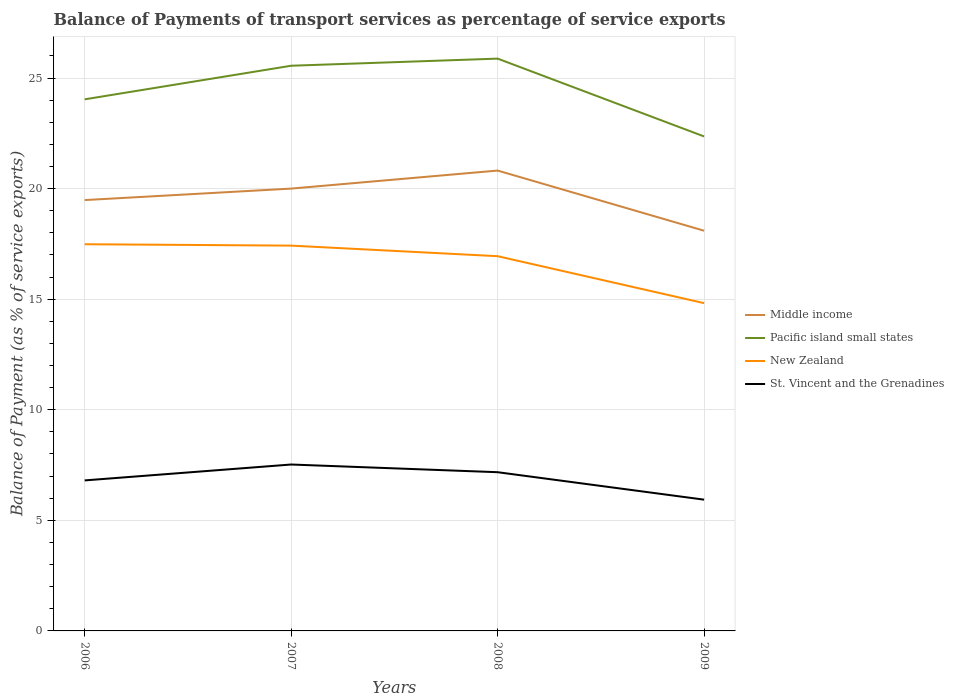Is the number of lines equal to the number of legend labels?
Make the answer very short. Yes. Across all years, what is the maximum balance of payments of transport services in St. Vincent and the Grenadines?
Ensure brevity in your answer.  5.94. In which year was the balance of payments of transport services in Pacific island small states maximum?
Provide a short and direct response. 2009. What is the total balance of payments of transport services in Pacific island small states in the graph?
Give a very brief answer. -0.32. What is the difference between the highest and the second highest balance of payments of transport services in Middle income?
Your answer should be compact. 2.72. What is the difference between the highest and the lowest balance of payments of transport services in St. Vincent and the Grenadines?
Ensure brevity in your answer.  2. How many lines are there?
Give a very brief answer. 4. What is the difference between two consecutive major ticks on the Y-axis?
Your answer should be compact. 5. Are the values on the major ticks of Y-axis written in scientific E-notation?
Provide a succinct answer. No. Does the graph contain any zero values?
Your answer should be very brief. No. How are the legend labels stacked?
Make the answer very short. Vertical. What is the title of the graph?
Your answer should be compact. Balance of Payments of transport services as percentage of service exports. Does "Libya" appear as one of the legend labels in the graph?
Your response must be concise. No. What is the label or title of the Y-axis?
Keep it short and to the point. Balance of Payment (as % of service exports). What is the Balance of Payment (as % of service exports) of Middle income in 2006?
Keep it short and to the point. 19.48. What is the Balance of Payment (as % of service exports) in Pacific island small states in 2006?
Make the answer very short. 24.04. What is the Balance of Payment (as % of service exports) of New Zealand in 2006?
Ensure brevity in your answer.  17.48. What is the Balance of Payment (as % of service exports) of St. Vincent and the Grenadines in 2006?
Offer a very short reply. 6.81. What is the Balance of Payment (as % of service exports) in Middle income in 2007?
Your response must be concise. 20. What is the Balance of Payment (as % of service exports) in Pacific island small states in 2007?
Offer a very short reply. 25.56. What is the Balance of Payment (as % of service exports) in New Zealand in 2007?
Your response must be concise. 17.42. What is the Balance of Payment (as % of service exports) of St. Vincent and the Grenadines in 2007?
Provide a short and direct response. 7.52. What is the Balance of Payment (as % of service exports) in Middle income in 2008?
Give a very brief answer. 20.82. What is the Balance of Payment (as % of service exports) of Pacific island small states in 2008?
Keep it short and to the point. 25.88. What is the Balance of Payment (as % of service exports) of New Zealand in 2008?
Give a very brief answer. 16.94. What is the Balance of Payment (as % of service exports) of St. Vincent and the Grenadines in 2008?
Give a very brief answer. 7.18. What is the Balance of Payment (as % of service exports) of Middle income in 2009?
Your response must be concise. 18.1. What is the Balance of Payment (as % of service exports) of Pacific island small states in 2009?
Give a very brief answer. 22.36. What is the Balance of Payment (as % of service exports) in New Zealand in 2009?
Make the answer very short. 14.82. What is the Balance of Payment (as % of service exports) of St. Vincent and the Grenadines in 2009?
Provide a short and direct response. 5.94. Across all years, what is the maximum Balance of Payment (as % of service exports) in Middle income?
Provide a short and direct response. 20.82. Across all years, what is the maximum Balance of Payment (as % of service exports) in Pacific island small states?
Your response must be concise. 25.88. Across all years, what is the maximum Balance of Payment (as % of service exports) in New Zealand?
Your answer should be compact. 17.48. Across all years, what is the maximum Balance of Payment (as % of service exports) in St. Vincent and the Grenadines?
Make the answer very short. 7.52. Across all years, what is the minimum Balance of Payment (as % of service exports) of Middle income?
Give a very brief answer. 18.1. Across all years, what is the minimum Balance of Payment (as % of service exports) of Pacific island small states?
Offer a very short reply. 22.36. Across all years, what is the minimum Balance of Payment (as % of service exports) in New Zealand?
Provide a succinct answer. 14.82. Across all years, what is the minimum Balance of Payment (as % of service exports) of St. Vincent and the Grenadines?
Your response must be concise. 5.94. What is the total Balance of Payment (as % of service exports) in Middle income in the graph?
Give a very brief answer. 78.39. What is the total Balance of Payment (as % of service exports) in Pacific island small states in the graph?
Your response must be concise. 97.83. What is the total Balance of Payment (as % of service exports) of New Zealand in the graph?
Give a very brief answer. 66.67. What is the total Balance of Payment (as % of service exports) of St. Vincent and the Grenadines in the graph?
Offer a very short reply. 27.44. What is the difference between the Balance of Payment (as % of service exports) in Middle income in 2006 and that in 2007?
Provide a short and direct response. -0.52. What is the difference between the Balance of Payment (as % of service exports) of Pacific island small states in 2006 and that in 2007?
Give a very brief answer. -1.52. What is the difference between the Balance of Payment (as % of service exports) of New Zealand in 2006 and that in 2007?
Keep it short and to the point. 0.06. What is the difference between the Balance of Payment (as % of service exports) in St. Vincent and the Grenadines in 2006 and that in 2007?
Offer a terse response. -0.72. What is the difference between the Balance of Payment (as % of service exports) in Middle income in 2006 and that in 2008?
Your answer should be compact. -1.33. What is the difference between the Balance of Payment (as % of service exports) of Pacific island small states in 2006 and that in 2008?
Your response must be concise. -1.84. What is the difference between the Balance of Payment (as % of service exports) of New Zealand in 2006 and that in 2008?
Ensure brevity in your answer.  0.54. What is the difference between the Balance of Payment (as % of service exports) in St. Vincent and the Grenadines in 2006 and that in 2008?
Your response must be concise. -0.37. What is the difference between the Balance of Payment (as % of service exports) in Middle income in 2006 and that in 2009?
Ensure brevity in your answer.  1.39. What is the difference between the Balance of Payment (as % of service exports) in Pacific island small states in 2006 and that in 2009?
Make the answer very short. 1.68. What is the difference between the Balance of Payment (as % of service exports) in New Zealand in 2006 and that in 2009?
Provide a succinct answer. 2.66. What is the difference between the Balance of Payment (as % of service exports) of St. Vincent and the Grenadines in 2006 and that in 2009?
Provide a short and direct response. 0.87. What is the difference between the Balance of Payment (as % of service exports) in Middle income in 2007 and that in 2008?
Provide a succinct answer. -0.82. What is the difference between the Balance of Payment (as % of service exports) of Pacific island small states in 2007 and that in 2008?
Make the answer very short. -0.32. What is the difference between the Balance of Payment (as % of service exports) of New Zealand in 2007 and that in 2008?
Provide a succinct answer. 0.48. What is the difference between the Balance of Payment (as % of service exports) in St. Vincent and the Grenadines in 2007 and that in 2008?
Make the answer very short. 0.35. What is the difference between the Balance of Payment (as % of service exports) of Middle income in 2007 and that in 2009?
Make the answer very short. 1.91. What is the difference between the Balance of Payment (as % of service exports) in Pacific island small states in 2007 and that in 2009?
Offer a very short reply. 3.2. What is the difference between the Balance of Payment (as % of service exports) in New Zealand in 2007 and that in 2009?
Offer a terse response. 2.6. What is the difference between the Balance of Payment (as % of service exports) in St. Vincent and the Grenadines in 2007 and that in 2009?
Offer a very short reply. 1.59. What is the difference between the Balance of Payment (as % of service exports) in Middle income in 2008 and that in 2009?
Keep it short and to the point. 2.72. What is the difference between the Balance of Payment (as % of service exports) of Pacific island small states in 2008 and that in 2009?
Your answer should be very brief. 3.52. What is the difference between the Balance of Payment (as % of service exports) of New Zealand in 2008 and that in 2009?
Your answer should be compact. 2.12. What is the difference between the Balance of Payment (as % of service exports) in St. Vincent and the Grenadines in 2008 and that in 2009?
Your answer should be very brief. 1.24. What is the difference between the Balance of Payment (as % of service exports) of Middle income in 2006 and the Balance of Payment (as % of service exports) of Pacific island small states in 2007?
Your answer should be very brief. -6.07. What is the difference between the Balance of Payment (as % of service exports) in Middle income in 2006 and the Balance of Payment (as % of service exports) in New Zealand in 2007?
Provide a short and direct response. 2.06. What is the difference between the Balance of Payment (as % of service exports) of Middle income in 2006 and the Balance of Payment (as % of service exports) of St. Vincent and the Grenadines in 2007?
Your answer should be very brief. 11.96. What is the difference between the Balance of Payment (as % of service exports) of Pacific island small states in 2006 and the Balance of Payment (as % of service exports) of New Zealand in 2007?
Keep it short and to the point. 6.62. What is the difference between the Balance of Payment (as % of service exports) of Pacific island small states in 2006 and the Balance of Payment (as % of service exports) of St. Vincent and the Grenadines in 2007?
Your answer should be very brief. 16.51. What is the difference between the Balance of Payment (as % of service exports) of New Zealand in 2006 and the Balance of Payment (as % of service exports) of St. Vincent and the Grenadines in 2007?
Keep it short and to the point. 9.96. What is the difference between the Balance of Payment (as % of service exports) of Middle income in 2006 and the Balance of Payment (as % of service exports) of Pacific island small states in 2008?
Offer a very short reply. -6.4. What is the difference between the Balance of Payment (as % of service exports) of Middle income in 2006 and the Balance of Payment (as % of service exports) of New Zealand in 2008?
Give a very brief answer. 2.54. What is the difference between the Balance of Payment (as % of service exports) in Middle income in 2006 and the Balance of Payment (as % of service exports) in St. Vincent and the Grenadines in 2008?
Ensure brevity in your answer.  12.3. What is the difference between the Balance of Payment (as % of service exports) of Pacific island small states in 2006 and the Balance of Payment (as % of service exports) of New Zealand in 2008?
Give a very brief answer. 7.09. What is the difference between the Balance of Payment (as % of service exports) in Pacific island small states in 2006 and the Balance of Payment (as % of service exports) in St. Vincent and the Grenadines in 2008?
Ensure brevity in your answer.  16.86. What is the difference between the Balance of Payment (as % of service exports) of New Zealand in 2006 and the Balance of Payment (as % of service exports) of St. Vincent and the Grenadines in 2008?
Provide a succinct answer. 10.31. What is the difference between the Balance of Payment (as % of service exports) of Middle income in 2006 and the Balance of Payment (as % of service exports) of Pacific island small states in 2009?
Provide a succinct answer. -2.88. What is the difference between the Balance of Payment (as % of service exports) in Middle income in 2006 and the Balance of Payment (as % of service exports) in New Zealand in 2009?
Your answer should be compact. 4.66. What is the difference between the Balance of Payment (as % of service exports) in Middle income in 2006 and the Balance of Payment (as % of service exports) in St. Vincent and the Grenadines in 2009?
Your answer should be very brief. 13.55. What is the difference between the Balance of Payment (as % of service exports) of Pacific island small states in 2006 and the Balance of Payment (as % of service exports) of New Zealand in 2009?
Offer a very short reply. 9.22. What is the difference between the Balance of Payment (as % of service exports) of Pacific island small states in 2006 and the Balance of Payment (as % of service exports) of St. Vincent and the Grenadines in 2009?
Offer a very short reply. 18.1. What is the difference between the Balance of Payment (as % of service exports) of New Zealand in 2006 and the Balance of Payment (as % of service exports) of St. Vincent and the Grenadines in 2009?
Provide a short and direct response. 11.55. What is the difference between the Balance of Payment (as % of service exports) of Middle income in 2007 and the Balance of Payment (as % of service exports) of Pacific island small states in 2008?
Offer a very short reply. -5.88. What is the difference between the Balance of Payment (as % of service exports) in Middle income in 2007 and the Balance of Payment (as % of service exports) in New Zealand in 2008?
Provide a short and direct response. 3.06. What is the difference between the Balance of Payment (as % of service exports) of Middle income in 2007 and the Balance of Payment (as % of service exports) of St. Vincent and the Grenadines in 2008?
Your answer should be compact. 12.82. What is the difference between the Balance of Payment (as % of service exports) of Pacific island small states in 2007 and the Balance of Payment (as % of service exports) of New Zealand in 2008?
Your answer should be very brief. 8.61. What is the difference between the Balance of Payment (as % of service exports) in Pacific island small states in 2007 and the Balance of Payment (as % of service exports) in St. Vincent and the Grenadines in 2008?
Your answer should be very brief. 18.38. What is the difference between the Balance of Payment (as % of service exports) in New Zealand in 2007 and the Balance of Payment (as % of service exports) in St. Vincent and the Grenadines in 2008?
Your answer should be compact. 10.25. What is the difference between the Balance of Payment (as % of service exports) in Middle income in 2007 and the Balance of Payment (as % of service exports) in Pacific island small states in 2009?
Keep it short and to the point. -2.36. What is the difference between the Balance of Payment (as % of service exports) of Middle income in 2007 and the Balance of Payment (as % of service exports) of New Zealand in 2009?
Keep it short and to the point. 5.18. What is the difference between the Balance of Payment (as % of service exports) of Middle income in 2007 and the Balance of Payment (as % of service exports) of St. Vincent and the Grenadines in 2009?
Offer a terse response. 14.07. What is the difference between the Balance of Payment (as % of service exports) of Pacific island small states in 2007 and the Balance of Payment (as % of service exports) of New Zealand in 2009?
Provide a short and direct response. 10.74. What is the difference between the Balance of Payment (as % of service exports) in Pacific island small states in 2007 and the Balance of Payment (as % of service exports) in St. Vincent and the Grenadines in 2009?
Make the answer very short. 19.62. What is the difference between the Balance of Payment (as % of service exports) in New Zealand in 2007 and the Balance of Payment (as % of service exports) in St. Vincent and the Grenadines in 2009?
Provide a short and direct response. 11.49. What is the difference between the Balance of Payment (as % of service exports) in Middle income in 2008 and the Balance of Payment (as % of service exports) in Pacific island small states in 2009?
Keep it short and to the point. -1.54. What is the difference between the Balance of Payment (as % of service exports) in Middle income in 2008 and the Balance of Payment (as % of service exports) in New Zealand in 2009?
Give a very brief answer. 6. What is the difference between the Balance of Payment (as % of service exports) of Middle income in 2008 and the Balance of Payment (as % of service exports) of St. Vincent and the Grenadines in 2009?
Provide a succinct answer. 14.88. What is the difference between the Balance of Payment (as % of service exports) in Pacific island small states in 2008 and the Balance of Payment (as % of service exports) in New Zealand in 2009?
Offer a terse response. 11.06. What is the difference between the Balance of Payment (as % of service exports) of Pacific island small states in 2008 and the Balance of Payment (as % of service exports) of St. Vincent and the Grenadines in 2009?
Offer a very short reply. 19.94. What is the difference between the Balance of Payment (as % of service exports) of New Zealand in 2008 and the Balance of Payment (as % of service exports) of St. Vincent and the Grenadines in 2009?
Provide a succinct answer. 11.01. What is the average Balance of Payment (as % of service exports) in Middle income per year?
Offer a terse response. 19.6. What is the average Balance of Payment (as % of service exports) in Pacific island small states per year?
Ensure brevity in your answer.  24.46. What is the average Balance of Payment (as % of service exports) in New Zealand per year?
Your answer should be compact. 16.67. What is the average Balance of Payment (as % of service exports) of St. Vincent and the Grenadines per year?
Give a very brief answer. 6.86. In the year 2006, what is the difference between the Balance of Payment (as % of service exports) in Middle income and Balance of Payment (as % of service exports) in Pacific island small states?
Your answer should be very brief. -4.56. In the year 2006, what is the difference between the Balance of Payment (as % of service exports) of Middle income and Balance of Payment (as % of service exports) of New Zealand?
Provide a short and direct response. 2. In the year 2006, what is the difference between the Balance of Payment (as % of service exports) in Middle income and Balance of Payment (as % of service exports) in St. Vincent and the Grenadines?
Make the answer very short. 12.68. In the year 2006, what is the difference between the Balance of Payment (as % of service exports) in Pacific island small states and Balance of Payment (as % of service exports) in New Zealand?
Offer a very short reply. 6.55. In the year 2006, what is the difference between the Balance of Payment (as % of service exports) in Pacific island small states and Balance of Payment (as % of service exports) in St. Vincent and the Grenadines?
Your answer should be compact. 17.23. In the year 2006, what is the difference between the Balance of Payment (as % of service exports) in New Zealand and Balance of Payment (as % of service exports) in St. Vincent and the Grenadines?
Provide a succinct answer. 10.68. In the year 2007, what is the difference between the Balance of Payment (as % of service exports) of Middle income and Balance of Payment (as % of service exports) of Pacific island small states?
Provide a short and direct response. -5.56. In the year 2007, what is the difference between the Balance of Payment (as % of service exports) of Middle income and Balance of Payment (as % of service exports) of New Zealand?
Ensure brevity in your answer.  2.58. In the year 2007, what is the difference between the Balance of Payment (as % of service exports) in Middle income and Balance of Payment (as % of service exports) in St. Vincent and the Grenadines?
Keep it short and to the point. 12.48. In the year 2007, what is the difference between the Balance of Payment (as % of service exports) in Pacific island small states and Balance of Payment (as % of service exports) in New Zealand?
Give a very brief answer. 8.13. In the year 2007, what is the difference between the Balance of Payment (as % of service exports) of Pacific island small states and Balance of Payment (as % of service exports) of St. Vincent and the Grenadines?
Offer a very short reply. 18.03. In the year 2007, what is the difference between the Balance of Payment (as % of service exports) of New Zealand and Balance of Payment (as % of service exports) of St. Vincent and the Grenadines?
Your response must be concise. 9.9. In the year 2008, what is the difference between the Balance of Payment (as % of service exports) of Middle income and Balance of Payment (as % of service exports) of Pacific island small states?
Offer a very short reply. -5.06. In the year 2008, what is the difference between the Balance of Payment (as % of service exports) in Middle income and Balance of Payment (as % of service exports) in New Zealand?
Offer a very short reply. 3.87. In the year 2008, what is the difference between the Balance of Payment (as % of service exports) of Middle income and Balance of Payment (as % of service exports) of St. Vincent and the Grenadines?
Make the answer very short. 13.64. In the year 2008, what is the difference between the Balance of Payment (as % of service exports) of Pacific island small states and Balance of Payment (as % of service exports) of New Zealand?
Offer a very short reply. 8.93. In the year 2008, what is the difference between the Balance of Payment (as % of service exports) in Pacific island small states and Balance of Payment (as % of service exports) in St. Vincent and the Grenadines?
Offer a very short reply. 18.7. In the year 2008, what is the difference between the Balance of Payment (as % of service exports) in New Zealand and Balance of Payment (as % of service exports) in St. Vincent and the Grenadines?
Your response must be concise. 9.77. In the year 2009, what is the difference between the Balance of Payment (as % of service exports) in Middle income and Balance of Payment (as % of service exports) in Pacific island small states?
Your answer should be very brief. -4.26. In the year 2009, what is the difference between the Balance of Payment (as % of service exports) of Middle income and Balance of Payment (as % of service exports) of New Zealand?
Keep it short and to the point. 3.28. In the year 2009, what is the difference between the Balance of Payment (as % of service exports) in Middle income and Balance of Payment (as % of service exports) in St. Vincent and the Grenadines?
Offer a terse response. 12.16. In the year 2009, what is the difference between the Balance of Payment (as % of service exports) of Pacific island small states and Balance of Payment (as % of service exports) of New Zealand?
Provide a short and direct response. 7.54. In the year 2009, what is the difference between the Balance of Payment (as % of service exports) of Pacific island small states and Balance of Payment (as % of service exports) of St. Vincent and the Grenadines?
Your response must be concise. 16.42. In the year 2009, what is the difference between the Balance of Payment (as % of service exports) in New Zealand and Balance of Payment (as % of service exports) in St. Vincent and the Grenadines?
Your response must be concise. 8.89. What is the ratio of the Balance of Payment (as % of service exports) in Pacific island small states in 2006 to that in 2007?
Provide a short and direct response. 0.94. What is the ratio of the Balance of Payment (as % of service exports) in New Zealand in 2006 to that in 2007?
Make the answer very short. 1. What is the ratio of the Balance of Payment (as % of service exports) of St. Vincent and the Grenadines in 2006 to that in 2007?
Provide a short and direct response. 0.9. What is the ratio of the Balance of Payment (as % of service exports) in Middle income in 2006 to that in 2008?
Give a very brief answer. 0.94. What is the ratio of the Balance of Payment (as % of service exports) in Pacific island small states in 2006 to that in 2008?
Provide a succinct answer. 0.93. What is the ratio of the Balance of Payment (as % of service exports) of New Zealand in 2006 to that in 2008?
Keep it short and to the point. 1.03. What is the ratio of the Balance of Payment (as % of service exports) of St. Vincent and the Grenadines in 2006 to that in 2008?
Make the answer very short. 0.95. What is the ratio of the Balance of Payment (as % of service exports) in Middle income in 2006 to that in 2009?
Ensure brevity in your answer.  1.08. What is the ratio of the Balance of Payment (as % of service exports) in Pacific island small states in 2006 to that in 2009?
Make the answer very short. 1.08. What is the ratio of the Balance of Payment (as % of service exports) in New Zealand in 2006 to that in 2009?
Provide a short and direct response. 1.18. What is the ratio of the Balance of Payment (as % of service exports) of St. Vincent and the Grenadines in 2006 to that in 2009?
Offer a very short reply. 1.15. What is the ratio of the Balance of Payment (as % of service exports) of Middle income in 2007 to that in 2008?
Offer a very short reply. 0.96. What is the ratio of the Balance of Payment (as % of service exports) of Pacific island small states in 2007 to that in 2008?
Your response must be concise. 0.99. What is the ratio of the Balance of Payment (as % of service exports) of New Zealand in 2007 to that in 2008?
Provide a succinct answer. 1.03. What is the ratio of the Balance of Payment (as % of service exports) of St. Vincent and the Grenadines in 2007 to that in 2008?
Your answer should be very brief. 1.05. What is the ratio of the Balance of Payment (as % of service exports) of Middle income in 2007 to that in 2009?
Ensure brevity in your answer.  1.11. What is the ratio of the Balance of Payment (as % of service exports) of Pacific island small states in 2007 to that in 2009?
Ensure brevity in your answer.  1.14. What is the ratio of the Balance of Payment (as % of service exports) in New Zealand in 2007 to that in 2009?
Your response must be concise. 1.18. What is the ratio of the Balance of Payment (as % of service exports) in St. Vincent and the Grenadines in 2007 to that in 2009?
Offer a terse response. 1.27. What is the ratio of the Balance of Payment (as % of service exports) in Middle income in 2008 to that in 2009?
Offer a very short reply. 1.15. What is the ratio of the Balance of Payment (as % of service exports) of Pacific island small states in 2008 to that in 2009?
Give a very brief answer. 1.16. What is the ratio of the Balance of Payment (as % of service exports) of New Zealand in 2008 to that in 2009?
Make the answer very short. 1.14. What is the ratio of the Balance of Payment (as % of service exports) in St. Vincent and the Grenadines in 2008 to that in 2009?
Offer a very short reply. 1.21. What is the difference between the highest and the second highest Balance of Payment (as % of service exports) in Middle income?
Make the answer very short. 0.82. What is the difference between the highest and the second highest Balance of Payment (as % of service exports) of Pacific island small states?
Ensure brevity in your answer.  0.32. What is the difference between the highest and the second highest Balance of Payment (as % of service exports) in New Zealand?
Offer a very short reply. 0.06. What is the difference between the highest and the second highest Balance of Payment (as % of service exports) in St. Vincent and the Grenadines?
Keep it short and to the point. 0.35. What is the difference between the highest and the lowest Balance of Payment (as % of service exports) of Middle income?
Offer a terse response. 2.72. What is the difference between the highest and the lowest Balance of Payment (as % of service exports) in Pacific island small states?
Offer a very short reply. 3.52. What is the difference between the highest and the lowest Balance of Payment (as % of service exports) of New Zealand?
Offer a terse response. 2.66. What is the difference between the highest and the lowest Balance of Payment (as % of service exports) of St. Vincent and the Grenadines?
Offer a terse response. 1.59. 